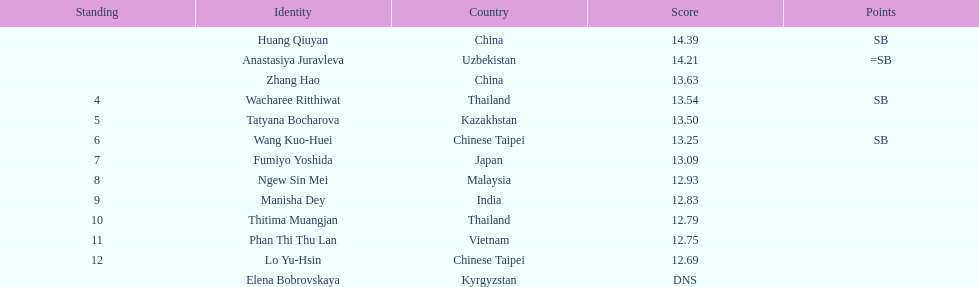What nationality was the woman who won first place? China. 